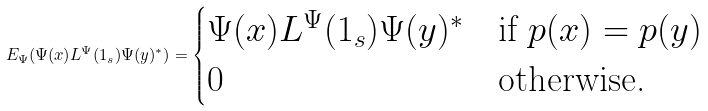<formula> <loc_0><loc_0><loc_500><loc_500>E _ { \Psi } ( \Psi ( x ) L ^ { \Psi } ( 1 _ { s } ) \Psi ( y ) ^ { * } ) = \begin{cases} \Psi ( x ) L ^ { \Psi } ( 1 _ { s } ) \Psi ( y ) ^ { * } & \text {if $p(x) = p(y)$} \\ 0 & \text {otherwise.} \end{cases}</formula> 